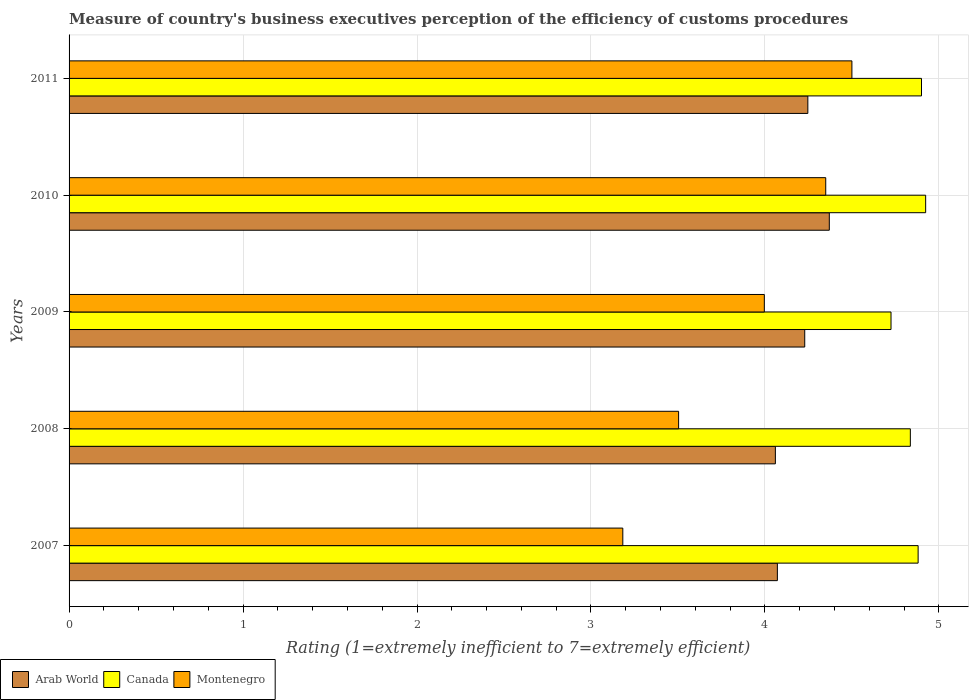Are the number of bars on each tick of the Y-axis equal?
Your answer should be compact. Yes. How many bars are there on the 4th tick from the top?
Make the answer very short. 3. How many bars are there on the 3rd tick from the bottom?
Offer a very short reply. 3. What is the rating of the efficiency of customs procedure in Arab World in 2008?
Offer a very short reply. 4.06. Across all years, what is the maximum rating of the efficiency of customs procedure in Arab World?
Ensure brevity in your answer.  4.37. Across all years, what is the minimum rating of the efficiency of customs procedure in Arab World?
Your answer should be compact. 4.06. In which year was the rating of the efficiency of customs procedure in Arab World maximum?
Keep it short and to the point. 2010. In which year was the rating of the efficiency of customs procedure in Arab World minimum?
Ensure brevity in your answer.  2008. What is the total rating of the efficiency of customs procedure in Canada in the graph?
Your response must be concise. 24.27. What is the difference between the rating of the efficiency of customs procedure in Montenegro in 2008 and that in 2011?
Provide a succinct answer. -1. What is the difference between the rating of the efficiency of customs procedure in Arab World in 2009 and the rating of the efficiency of customs procedure in Canada in 2011?
Your response must be concise. -0.67. What is the average rating of the efficiency of customs procedure in Canada per year?
Offer a terse response. 4.85. In the year 2007, what is the difference between the rating of the efficiency of customs procedure in Arab World and rating of the efficiency of customs procedure in Canada?
Offer a very short reply. -0.81. In how many years, is the rating of the efficiency of customs procedure in Arab World greater than 0.8 ?
Offer a terse response. 5. What is the ratio of the rating of the efficiency of customs procedure in Montenegro in 2007 to that in 2011?
Provide a short and direct response. 0.71. Is the rating of the efficiency of customs procedure in Montenegro in 2009 less than that in 2010?
Your answer should be very brief. Yes. Is the difference between the rating of the efficiency of customs procedure in Arab World in 2008 and 2009 greater than the difference between the rating of the efficiency of customs procedure in Canada in 2008 and 2009?
Provide a short and direct response. No. What is the difference between the highest and the second highest rating of the efficiency of customs procedure in Arab World?
Ensure brevity in your answer.  0.12. What is the difference between the highest and the lowest rating of the efficiency of customs procedure in Canada?
Ensure brevity in your answer.  0.2. What does the 2nd bar from the top in 2010 represents?
Give a very brief answer. Canada. What does the 3rd bar from the bottom in 2009 represents?
Provide a short and direct response. Montenegro. Is it the case that in every year, the sum of the rating of the efficiency of customs procedure in Canada and rating of the efficiency of customs procedure in Montenegro is greater than the rating of the efficiency of customs procedure in Arab World?
Ensure brevity in your answer.  Yes. How many bars are there?
Keep it short and to the point. 15. Are all the bars in the graph horizontal?
Ensure brevity in your answer.  Yes. What is the difference between two consecutive major ticks on the X-axis?
Ensure brevity in your answer.  1. Are the values on the major ticks of X-axis written in scientific E-notation?
Ensure brevity in your answer.  No. Does the graph contain any zero values?
Provide a succinct answer. No. What is the title of the graph?
Your answer should be very brief. Measure of country's business executives perception of the efficiency of customs procedures. Does "Latin America(all income levels)" appear as one of the legend labels in the graph?
Your answer should be very brief. No. What is the label or title of the X-axis?
Keep it short and to the point. Rating (1=extremely inefficient to 7=extremely efficient). What is the label or title of the Y-axis?
Give a very brief answer. Years. What is the Rating (1=extremely inefficient to 7=extremely efficient) of Arab World in 2007?
Offer a terse response. 4.07. What is the Rating (1=extremely inefficient to 7=extremely efficient) of Canada in 2007?
Your response must be concise. 4.88. What is the Rating (1=extremely inefficient to 7=extremely efficient) of Montenegro in 2007?
Your response must be concise. 3.18. What is the Rating (1=extremely inefficient to 7=extremely efficient) of Arab World in 2008?
Provide a succinct answer. 4.06. What is the Rating (1=extremely inefficient to 7=extremely efficient) in Canada in 2008?
Offer a very short reply. 4.84. What is the Rating (1=extremely inefficient to 7=extremely efficient) in Montenegro in 2008?
Your response must be concise. 3.5. What is the Rating (1=extremely inefficient to 7=extremely efficient) in Arab World in 2009?
Provide a succinct answer. 4.23. What is the Rating (1=extremely inefficient to 7=extremely efficient) of Canada in 2009?
Make the answer very short. 4.72. What is the Rating (1=extremely inefficient to 7=extremely efficient) of Montenegro in 2009?
Offer a terse response. 4. What is the Rating (1=extremely inefficient to 7=extremely efficient) in Arab World in 2010?
Give a very brief answer. 4.37. What is the Rating (1=extremely inefficient to 7=extremely efficient) in Canada in 2010?
Make the answer very short. 4.92. What is the Rating (1=extremely inefficient to 7=extremely efficient) of Montenegro in 2010?
Offer a very short reply. 4.35. What is the Rating (1=extremely inefficient to 7=extremely efficient) of Arab World in 2011?
Offer a very short reply. 4.25. Across all years, what is the maximum Rating (1=extremely inefficient to 7=extremely efficient) in Arab World?
Provide a succinct answer. 4.37. Across all years, what is the maximum Rating (1=extremely inefficient to 7=extremely efficient) of Canada?
Offer a terse response. 4.92. Across all years, what is the minimum Rating (1=extremely inefficient to 7=extremely efficient) in Arab World?
Offer a terse response. 4.06. Across all years, what is the minimum Rating (1=extremely inefficient to 7=extremely efficient) in Canada?
Ensure brevity in your answer.  4.72. Across all years, what is the minimum Rating (1=extremely inefficient to 7=extremely efficient) in Montenegro?
Provide a succinct answer. 3.18. What is the total Rating (1=extremely inefficient to 7=extremely efficient) in Arab World in the graph?
Keep it short and to the point. 20.98. What is the total Rating (1=extremely inefficient to 7=extremely efficient) in Canada in the graph?
Offer a terse response. 24.27. What is the total Rating (1=extremely inefficient to 7=extremely efficient) of Montenegro in the graph?
Ensure brevity in your answer.  19.53. What is the difference between the Rating (1=extremely inefficient to 7=extremely efficient) in Arab World in 2007 and that in 2008?
Keep it short and to the point. 0.01. What is the difference between the Rating (1=extremely inefficient to 7=extremely efficient) of Canada in 2007 and that in 2008?
Make the answer very short. 0.04. What is the difference between the Rating (1=extremely inefficient to 7=extremely efficient) in Montenegro in 2007 and that in 2008?
Your response must be concise. -0.32. What is the difference between the Rating (1=extremely inefficient to 7=extremely efficient) of Arab World in 2007 and that in 2009?
Your answer should be compact. -0.16. What is the difference between the Rating (1=extremely inefficient to 7=extremely efficient) in Canada in 2007 and that in 2009?
Ensure brevity in your answer.  0.16. What is the difference between the Rating (1=extremely inefficient to 7=extremely efficient) in Montenegro in 2007 and that in 2009?
Keep it short and to the point. -0.81. What is the difference between the Rating (1=extremely inefficient to 7=extremely efficient) of Arab World in 2007 and that in 2010?
Ensure brevity in your answer.  -0.3. What is the difference between the Rating (1=extremely inefficient to 7=extremely efficient) of Canada in 2007 and that in 2010?
Provide a succinct answer. -0.04. What is the difference between the Rating (1=extremely inefficient to 7=extremely efficient) of Montenegro in 2007 and that in 2010?
Offer a very short reply. -1.17. What is the difference between the Rating (1=extremely inefficient to 7=extremely efficient) in Arab World in 2007 and that in 2011?
Your answer should be compact. -0.18. What is the difference between the Rating (1=extremely inefficient to 7=extremely efficient) in Canada in 2007 and that in 2011?
Ensure brevity in your answer.  -0.02. What is the difference between the Rating (1=extremely inefficient to 7=extremely efficient) in Montenegro in 2007 and that in 2011?
Your answer should be compact. -1.32. What is the difference between the Rating (1=extremely inefficient to 7=extremely efficient) of Arab World in 2008 and that in 2009?
Ensure brevity in your answer.  -0.17. What is the difference between the Rating (1=extremely inefficient to 7=extremely efficient) in Montenegro in 2008 and that in 2009?
Ensure brevity in your answer.  -0.49. What is the difference between the Rating (1=extremely inefficient to 7=extremely efficient) of Arab World in 2008 and that in 2010?
Offer a terse response. -0.31. What is the difference between the Rating (1=extremely inefficient to 7=extremely efficient) of Canada in 2008 and that in 2010?
Keep it short and to the point. -0.09. What is the difference between the Rating (1=extremely inefficient to 7=extremely efficient) in Montenegro in 2008 and that in 2010?
Ensure brevity in your answer.  -0.85. What is the difference between the Rating (1=extremely inefficient to 7=extremely efficient) of Arab World in 2008 and that in 2011?
Offer a very short reply. -0.19. What is the difference between the Rating (1=extremely inefficient to 7=extremely efficient) of Canada in 2008 and that in 2011?
Provide a succinct answer. -0.06. What is the difference between the Rating (1=extremely inefficient to 7=extremely efficient) in Montenegro in 2008 and that in 2011?
Provide a succinct answer. -1. What is the difference between the Rating (1=extremely inefficient to 7=extremely efficient) of Arab World in 2009 and that in 2010?
Provide a short and direct response. -0.14. What is the difference between the Rating (1=extremely inefficient to 7=extremely efficient) in Canada in 2009 and that in 2010?
Your answer should be compact. -0.2. What is the difference between the Rating (1=extremely inefficient to 7=extremely efficient) in Montenegro in 2009 and that in 2010?
Offer a very short reply. -0.35. What is the difference between the Rating (1=extremely inefficient to 7=extremely efficient) of Arab World in 2009 and that in 2011?
Keep it short and to the point. -0.02. What is the difference between the Rating (1=extremely inefficient to 7=extremely efficient) in Canada in 2009 and that in 2011?
Make the answer very short. -0.18. What is the difference between the Rating (1=extremely inefficient to 7=extremely efficient) of Montenegro in 2009 and that in 2011?
Offer a terse response. -0.5. What is the difference between the Rating (1=extremely inefficient to 7=extremely efficient) of Arab World in 2010 and that in 2011?
Give a very brief answer. 0.12. What is the difference between the Rating (1=extremely inefficient to 7=extremely efficient) of Canada in 2010 and that in 2011?
Offer a very short reply. 0.02. What is the difference between the Rating (1=extremely inefficient to 7=extremely efficient) of Montenegro in 2010 and that in 2011?
Provide a succinct answer. -0.15. What is the difference between the Rating (1=extremely inefficient to 7=extremely efficient) in Arab World in 2007 and the Rating (1=extremely inefficient to 7=extremely efficient) in Canada in 2008?
Your response must be concise. -0.76. What is the difference between the Rating (1=extremely inefficient to 7=extremely efficient) in Arab World in 2007 and the Rating (1=extremely inefficient to 7=extremely efficient) in Montenegro in 2008?
Provide a succinct answer. 0.57. What is the difference between the Rating (1=extremely inefficient to 7=extremely efficient) in Canada in 2007 and the Rating (1=extremely inefficient to 7=extremely efficient) in Montenegro in 2008?
Keep it short and to the point. 1.38. What is the difference between the Rating (1=extremely inefficient to 7=extremely efficient) in Arab World in 2007 and the Rating (1=extremely inefficient to 7=extremely efficient) in Canada in 2009?
Keep it short and to the point. -0.65. What is the difference between the Rating (1=extremely inefficient to 7=extremely efficient) in Arab World in 2007 and the Rating (1=extremely inefficient to 7=extremely efficient) in Montenegro in 2009?
Ensure brevity in your answer.  0.07. What is the difference between the Rating (1=extremely inefficient to 7=extremely efficient) of Canada in 2007 and the Rating (1=extremely inefficient to 7=extremely efficient) of Montenegro in 2009?
Your response must be concise. 0.88. What is the difference between the Rating (1=extremely inefficient to 7=extremely efficient) in Arab World in 2007 and the Rating (1=extremely inefficient to 7=extremely efficient) in Canada in 2010?
Your answer should be very brief. -0.85. What is the difference between the Rating (1=extremely inefficient to 7=extremely efficient) in Arab World in 2007 and the Rating (1=extremely inefficient to 7=extremely efficient) in Montenegro in 2010?
Offer a very short reply. -0.28. What is the difference between the Rating (1=extremely inefficient to 7=extremely efficient) of Canada in 2007 and the Rating (1=extremely inefficient to 7=extremely efficient) of Montenegro in 2010?
Your answer should be compact. 0.53. What is the difference between the Rating (1=extremely inefficient to 7=extremely efficient) of Arab World in 2007 and the Rating (1=extremely inefficient to 7=extremely efficient) of Canada in 2011?
Your answer should be very brief. -0.83. What is the difference between the Rating (1=extremely inefficient to 7=extremely efficient) in Arab World in 2007 and the Rating (1=extremely inefficient to 7=extremely efficient) in Montenegro in 2011?
Keep it short and to the point. -0.43. What is the difference between the Rating (1=extremely inefficient to 7=extremely efficient) of Canada in 2007 and the Rating (1=extremely inefficient to 7=extremely efficient) of Montenegro in 2011?
Offer a very short reply. 0.38. What is the difference between the Rating (1=extremely inefficient to 7=extremely efficient) in Arab World in 2008 and the Rating (1=extremely inefficient to 7=extremely efficient) in Canada in 2009?
Keep it short and to the point. -0.66. What is the difference between the Rating (1=extremely inefficient to 7=extremely efficient) of Arab World in 2008 and the Rating (1=extremely inefficient to 7=extremely efficient) of Montenegro in 2009?
Give a very brief answer. 0.06. What is the difference between the Rating (1=extremely inefficient to 7=extremely efficient) in Canada in 2008 and the Rating (1=extremely inefficient to 7=extremely efficient) in Montenegro in 2009?
Keep it short and to the point. 0.84. What is the difference between the Rating (1=extremely inefficient to 7=extremely efficient) in Arab World in 2008 and the Rating (1=extremely inefficient to 7=extremely efficient) in Canada in 2010?
Your answer should be compact. -0.86. What is the difference between the Rating (1=extremely inefficient to 7=extremely efficient) in Arab World in 2008 and the Rating (1=extremely inefficient to 7=extremely efficient) in Montenegro in 2010?
Keep it short and to the point. -0.29. What is the difference between the Rating (1=extremely inefficient to 7=extremely efficient) in Canada in 2008 and the Rating (1=extremely inefficient to 7=extremely efficient) in Montenegro in 2010?
Offer a terse response. 0.49. What is the difference between the Rating (1=extremely inefficient to 7=extremely efficient) of Arab World in 2008 and the Rating (1=extremely inefficient to 7=extremely efficient) of Canada in 2011?
Make the answer very short. -0.84. What is the difference between the Rating (1=extremely inefficient to 7=extremely efficient) of Arab World in 2008 and the Rating (1=extremely inefficient to 7=extremely efficient) of Montenegro in 2011?
Provide a succinct answer. -0.44. What is the difference between the Rating (1=extremely inefficient to 7=extremely efficient) in Canada in 2008 and the Rating (1=extremely inefficient to 7=extremely efficient) in Montenegro in 2011?
Provide a succinct answer. 0.34. What is the difference between the Rating (1=extremely inefficient to 7=extremely efficient) of Arab World in 2009 and the Rating (1=extremely inefficient to 7=extremely efficient) of Canada in 2010?
Give a very brief answer. -0.7. What is the difference between the Rating (1=extremely inefficient to 7=extremely efficient) in Arab World in 2009 and the Rating (1=extremely inefficient to 7=extremely efficient) in Montenegro in 2010?
Your response must be concise. -0.12. What is the difference between the Rating (1=extremely inefficient to 7=extremely efficient) in Canada in 2009 and the Rating (1=extremely inefficient to 7=extremely efficient) in Montenegro in 2010?
Make the answer very short. 0.38. What is the difference between the Rating (1=extremely inefficient to 7=extremely efficient) in Arab World in 2009 and the Rating (1=extremely inefficient to 7=extremely efficient) in Canada in 2011?
Ensure brevity in your answer.  -0.67. What is the difference between the Rating (1=extremely inefficient to 7=extremely efficient) of Arab World in 2009 and the Rating (1=extremely inefficient to 7=extremely efficient) of Montenegro in 2011?
Provide a succinct answer. -0.27. What is the difference between the Rating (1=extremely inefficient to 7=extremely efficient) of Canada in 2009 and the Rating (1=extremely inefficient to 7=extremely efficient) of Montenegro in 2011?
Your answer should be very brief. 0.22. What is the difference between the Rating (1=extremely inefficient to 7=extremely efficient) in Arab World in 2010 and the Rating (1=extremely inefficient to 7=extremely efficient) in Canada in 2011?
Ensure brevity in your answer.  -0.53. What is the difference between the Rating (1=extremely inefficient to 7=extremely efficient) of Arab World in 2010 and the Rating (1=extremely inefficient to 7=extremely efficient) of Montenegro in 2011?
Make the answer very short. -0.13. What is the difference between the Rating (1=extremely inefficient to 7=extremely efficient) of Canada in 2010 and the Rating (1=extremely inefficient to 7=extremely efficient) of Montenegro in 2011?
Ensure brevity in your answer.  0.42. What is the average Rating (1=extremely inefficient to 7=extremely efficient) in Arab World per year?
Ensure brevity in your answer.  4.2. What is the average Rating (1=extremely inefficient to 7=extremely efficient) in Canada per year?
Offer a very short reply. 4.85. What is the average Rating (1=extremely inefficient to 7=extremely efficient) in Montenegro per year?
Keep it short and to the point. 3.91. In the year 2007, what is the difference between the Rating (1=extremely inefficient to 7=extremely efficient) in Arab World and Rating (1=extremely inefficient to 7=extremely efficient) in Canada?
Your answer should be very brief. -0.81. In the year 2007, what is the difference between the Rating (1=extremely inefficient to 7=extremely efficient) of Arab World and Rating (1=extremely inefficient to 7=extremely efficient) of Montenegro?
Give a very brief answer. 0.89. In the year 2007, what is the difference between the Rating (1=extremely inefficient to 7=extremely efficient) of Canada and Rating (1=extremely inefficient to 7=extremely efficient) of Montenegro?
Provide a short and direct response. 1.7. In the year 2008, what is the difference between the Rating (1=extremely inefficient to 7=extremely efficient) in Arab World and Rating (1=extremely inefficient to 7=extremely efficient) in Canada?
Ensure brevity in your answer.  -0.78. In the year 2008, what is the difference between the Rating (1=extremely inefficient to 7=extremely efficient) of Arab World and Rating (1=extremely inefficient to 7=extremely efficient) of Montenegro?
Your answer should be compact. 0.56. In the year 2008, what is the difference between the Rating (1=extremely inefficient to 7=extremely efficient) in Canada and Rating (1=extremely inefficient to 7=extremely efficient) in Montenegro?
Offer a very short reply. 1.33. In the year 2009, what is the difference between the Rating (1=extremely inefficient to 7=extremely efficient) of Arab World and Rating (1=extremely inefficient to 7=extremely efficient) of Canada?
Ensure brevity in your answer.  -0.5. In the year 2009, what is the difference between the Rating (1=extremely inefficient to 7=extremely efficient) in Arab World and Rating (1=extremely inefficient to 7=extremely efficient) in Montenegro?
Give a very brief answer. 0.23. In the year 2009, what is the difference between the Rating (1=extremely inefficient to 7=extremely efficient) of Canada and Rating (1=extremely inefficient to 7=extremely efficient) of Montenegro?
Provide a short and direct response. 0.73. In the year 2010, what is the difference between the Rating (1=extremely inefficient to 7=extremely efficient) in Arab World and Rating (1=extremely inefficient to 7=extremely efficient) in Canada?
Your answer should be very brief. -0.55. In the year 2010, what is the difference between the Rating (1=extremely inefficient to 7=extremely efficient) of Arab World and Rating (1=extremely inefficient to 7=extremely efficient) of Montenegro?
Offer a very short reply. 0.02. In the year 2010, what is the difference between the Rating (1=extremely inefficient to 7=extremely efficient) of Canada and Rating (1=extremely inefficient to 7=extremely efficient) of Montenegro?
Offer a very short reply. 0.57. In the year 2011, what is the difference between the Rating (1=extremely inefficient to 7=extremely efficient) in Arab World and Rating (1=extremely inefficient to 7=extremely efficient) in Canada?
Your answer should be very brief. -0.65. In the year 2011, what is the difference between the Rating (1=extremely inefficient to 7=extremely efficient) in Arab World and Rating (1=extremely inefficient to 7=extremely efficient) in Montenegro?
Your answer should be compact. -0.25. What is the ratio of the Rating (1=extremely inefficient to 7=extremely efficient) in Arab World in 2007 to that in 2008?
Provide a succinct answer. 1. What is the ratio of the Rating (1=extremely inefficient to 7=extremely efficient) in Canada in 2007 to that in 2008?
Your answer should be very brief. 1.01. What is the ratio of the Rating (1=extremely inefficient to 7=extremely efficient) of Montenegro in 2007 to that in 2008?
Offer a very short reply. 0.91. What is the ratio of the Rating (1=extremely inefficient to 7=extremely efficient) in Arab World in 2007 to that in 2009?
Your answer should be compact. 0.96. What is the ratio of the Rating (1=extremely inefficient to 7=extremely efficient) of Canada in 2007 to that in 2009?
Ensure brevity in your answer.  1.03. What is the ratio of the Rating (1=extremely inefficient to 7=extremely efficient) in Montenegro in 2007 to that in 2009?
Offer a very short reply. 0.8. What is the ratio of the Rating (1=extremely inefficient to 7=extremely efficient) in Arab World in 2007 to that in 2010?
Offer a terse response. 0.93. What is the ratio of the Rating (1=extremely inefficient to 7=extremely efficient) of Montenegro in 2007 to that in 2010?
Give a very brief answer. 0.73. What is the ratio of the Rating (1=extremely inefficient to 7=extremely efficient) in Arab World in 2007 to that in 2011?
Keep it short and to the point. 0.96. What is the ratio of the Rating (1=extremely inefficient to 7=extremely efficient) in Canada in 2007 to that in 2011?
Offer a terse response. 1. What is the ratio of the Rating (1=extremely inefficient to 7=extremely efficient) in Montenegro in 2007 to that in 2011?
Give a very brief answer. 0.71. What is the ratio of the Rating (1=extremely inefficient to 7=extremely efficient) of Arab World in 2008 to that in 2009?
Give a very brief answer. 0.96. What is the ratio of the Rating (1=extremely inefficient to 7=extremely efficient) in Canada in 2008 to that in 2009?
Keep it short and to the point. 1.02. What is the ratio of the Rating (1=extremely inefficient to 7=extremely efficient) in Montenegro in 2008 to that in 2009?
Ensure brevity in your answer.  0.88. What is the ratio of the Rating (1=extremely inefficient to 7=extremely efficient) in Arab World in 2008 to that in 2010?
Offer a terse response. 0.93. What is the ratio of the Rating (1=extremely inefficient to 7=extremely efficient) of Canada in 2008 to that in 2010?
Give a very brief answer. 0.98. What is the ratio of the Rating (1=extremely inefficient to 7=extremely efficient) of Montenegro in 2008 to that in 2010?
Keep it short and to the point. 0.81. What is the ratio of the Rating (1=extremely inefficient to 7=extremely efficient) of Arab World in 2008 to that in 2011?
Give a very brief answer. 0.96. What is the ratio of the Rating (1=extremely inefficient to 7=extremely efficient) of Canada in 2008 to that in 2011?
Offer a terse response. 0.99. What is the ratio of the Rating (1=extremely inefficient to 7=extremely efficient) of Montenegro in 2008 to that in 2011?
Offer a terse response. 0.78. What is the ratio of the Rating (1=extremely inefficient to 7=extremely efficient) of Canada in 2009 to that in 2010?
Offer a very short reply. 0.96. What is the ratio of the Rating (1=extremely inefficient to 7=extremely efficient) of Montenegro in 2009 to that in 2010?
Make the answer very short. 0.92. What is the ratio of the Rating (1=extremely inefficient to 7=extremely efficient) of Canada in 2009 to that in 2011?
Offer a very short reply. 0.96. What is the ratio of the Rating (1=extremely inefficient to 7=extremely efficient) in Montenegro in 2009 to that in 2011?
Offer a terse response. 0.89. What is the ratio of the Rating (1=extremely inefficient to 7=extremely efficient) of Arab World in 2010 to that in 2011?
Give a very brief answer. 1.03. What is the ratio of the Rating (1=extremely inefficient to 7=extremely efficient) of Montenegro in 2010 to that in 2011?
Your answer should be very brief. 0.97. What is the difference between the highest and the second highest Rating (1=extremely inefficient to 7=extremely efficient) of Arab World?
Your answer should be compact. 0.12. What is the difference between the highest and the second highest Rating (1=extremely inefficient to 7=extremely efficient) of Canada?
Your answer should be compact. 0.02. What is the difference between the highest and the second highest Rating (1=extremely inefficient to 7=extremely efficient) of Montenegro?
Your response must be concise. 0.15. What is the difference between the highest and the lowest Rating (1=extremely inefficient to 7=extremely efficient) of Arab World?
Ensure brevity in your answer.  0.31. What is the difference between the highest and the lowest Rating (1=extremely inefficient to 7=extremely efficient) of Canada?
Give a very brief answer. 0.2. What is the difference between the highest and the lowest Rating (1=extremely inefficient to 7=extremely efficient) of Montenegro?
Your response must be concise. 1.32. 